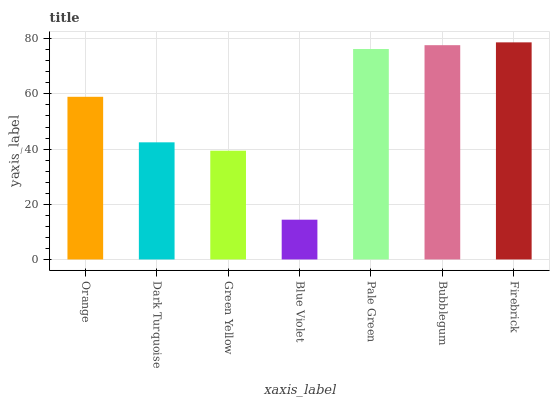Is Blue Violet the minimum?
Answer yes or no. Yes. Is Firebrick the maximum?
Answer yes or no. Yes. Is Dark Turquoise the minimum?
Answer yes or no. No. Is Dark Turquoise the maximum?
Answer yes or no. No. Is Orange greater than Dark Turquoise?
Answer yes or no. Yes. Is Dark Turquoise less than Orange?
Answer yes or no. Yes. Is Dark Turquoise greater than Orange?
Answer yes or no. No. Is Orange less than Dark Turquoise?
Answer yes or no. No. Is Orange the high median?
Answer yes or no. Yes. Is Orange the low median?
Answer yes or no. Yes. Is Dark Turquoise the high median?
Answer yes or no. No. Is Dark Turquoise the low median?
Answer yes or no. No. 